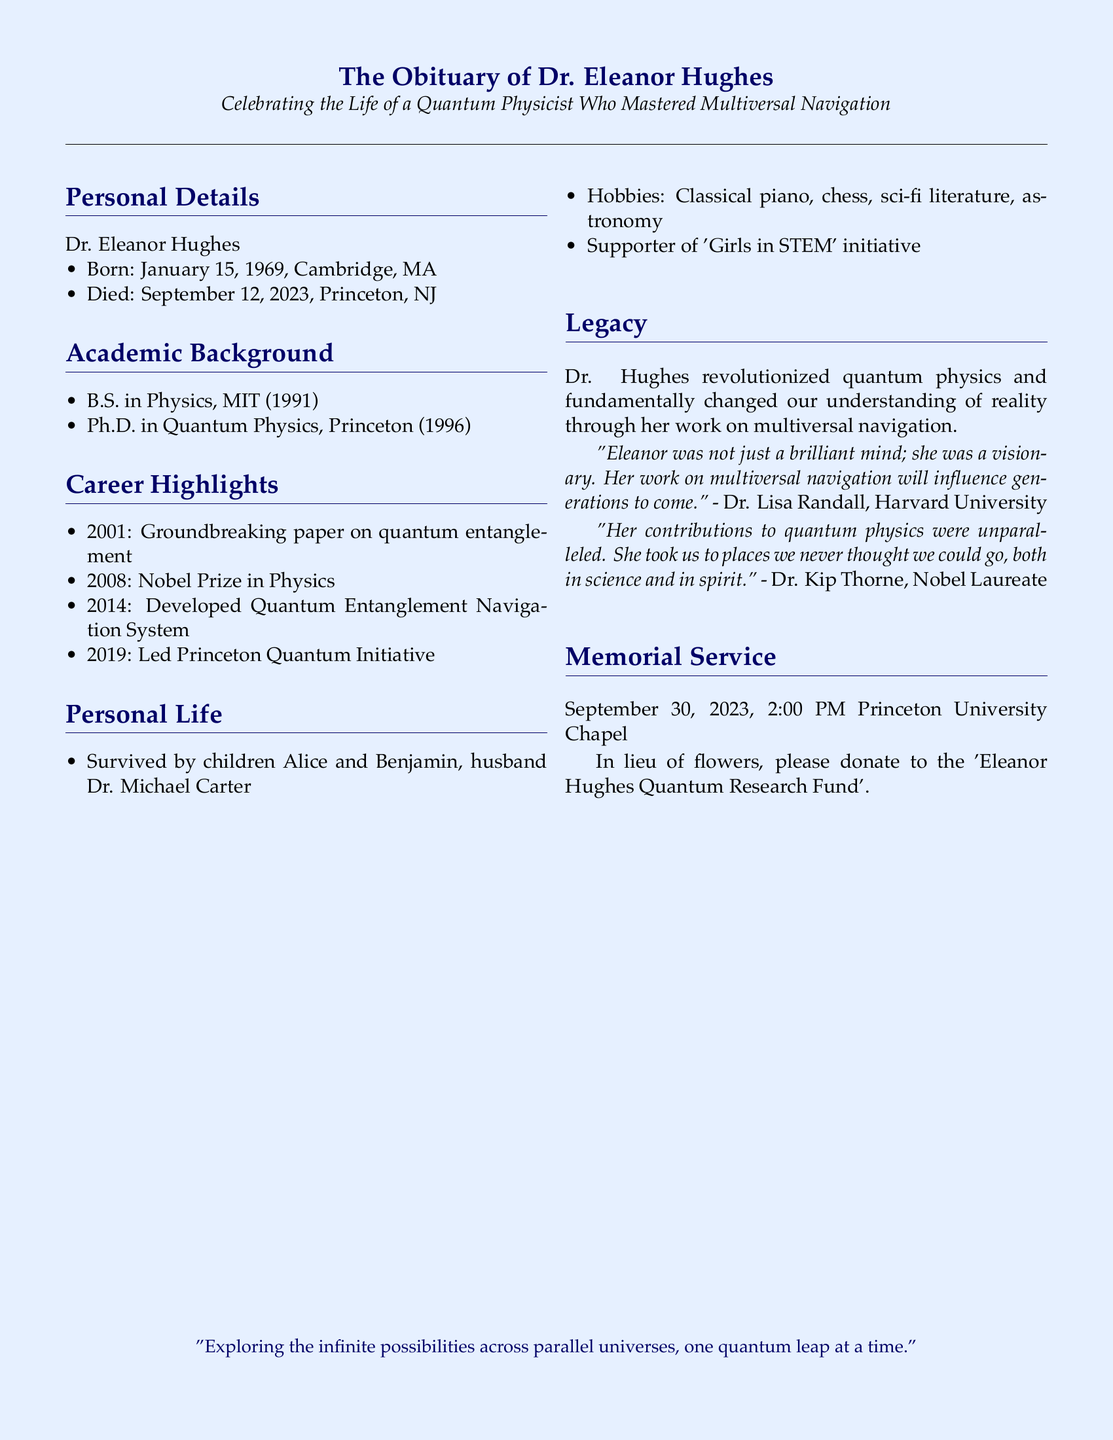What was Dr. Eleanor Hughes' birth date? The document mentions that Dr. Eleanor Hughes was born on January 15, 1969.
Answer: January 15, 1969 What university did Dr. Eleanor Hughes obtain her Ph.D. from? The obituary states that Dr. Hughes received her Ph.D. in Quantum Physics from Princeton.
Answer: Princeton When did Dr. Hughes win the Nobel Prize? According to the document, Dr. Hughes won the Nobel Prize in Physics in 2008.
Answer: 2008 What significant paper did Dr. Hughes publish in 2001? The document highlights her groundbreaking paper on quantum entanglement published in 2001.
Answer: Quantum entanglement Who are the survivors mentioned in Dr. Hughes' obituary? The obituary lists her children Alice and Benjamin, and husband Dr. Michael Carter as the survivors.
Answer: Alice and Benjamin, Dr. Michael Carter What initiative did Dr. Hughes support? The document states that Dr. Hughes was a supporter of the 'Girls in STEM' initiative.
Answer: 'Girls in STEM' What is the date and time of the memorial service? The document specifies that the memorial service is on September 30, 2023, at 2:00 PM.
Answer: September 30, 2023, 2:00 PM How did Dr. Thorne describe Dr. Hughes' contributions? Dr. Thorne's quote in the document describes her contributions as unparalleled, stating she took us to places we never thought we could go.
Answer: Unparalleled What type of research fund is mentioned for donations? The obituary mentions the 'Eleanor Hughes Quantum Research Fund' for donations in lieu of flowers.
Answer: 'Eleanor Hughes Quantum Research Fund' 